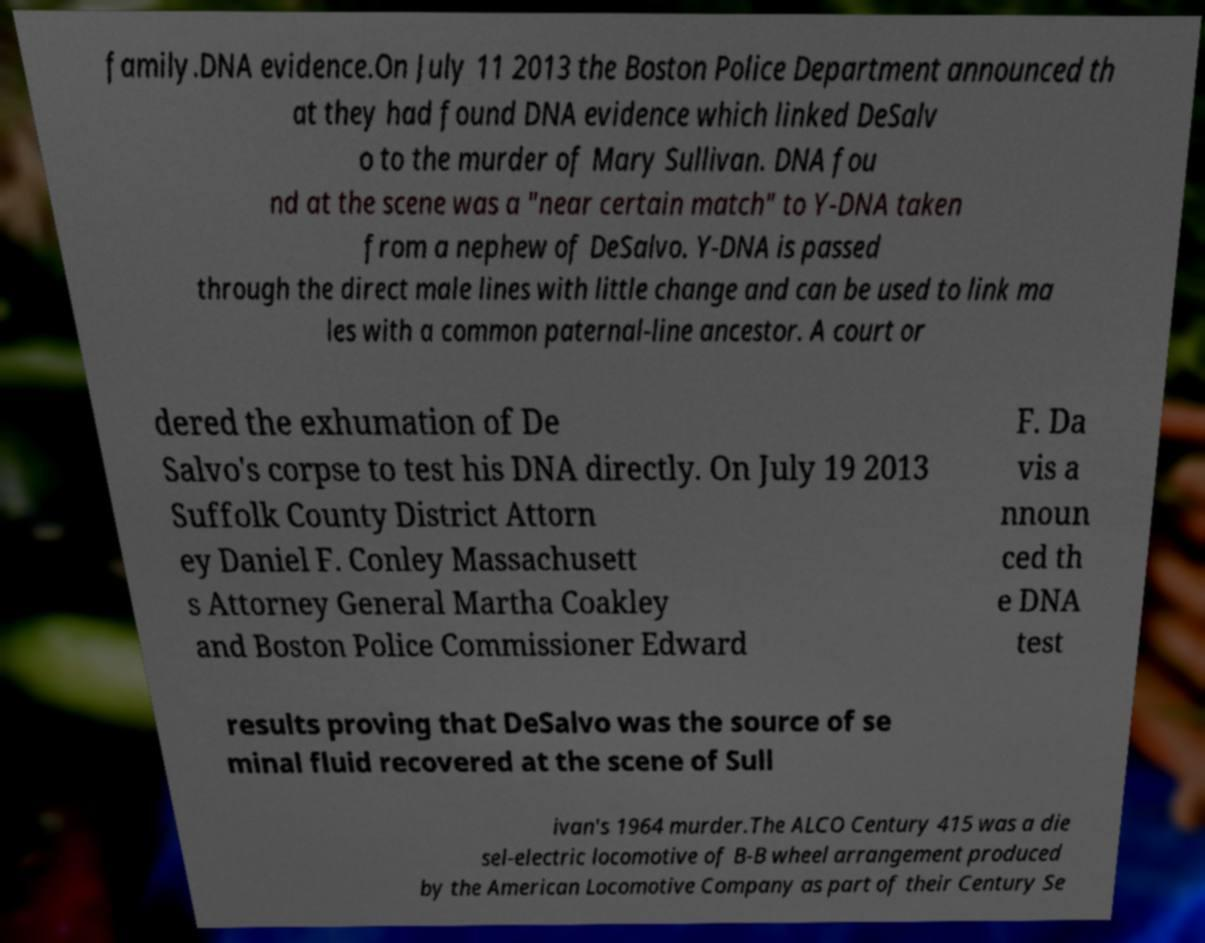I need the written content from this picture converted into text. Can you do that? family.DNA evidence.On July 11 2013 the Boston Police Department announced th at they had found DNA evidence which linked DeSalv o to the murder of Mary Sullivan. DNA fou nd at the scene was a "near certain match" to Y-DNA taken from a nephew of DeSalvo. Y-DNA is passed through the direct male lines with little change and can be used to link ma les with a common paternal-line ancestor. A court or dered the exhumation of De Salvo's corpse to test his DNA directly. On July 19 2013 Suffolk County District Attorn ey Daniel F. Conley Massachusett s Attorney General Martha Coakley and Boston Police Commissioner Edward F. Da vis a nnoun ced th e DNA test results proving that DeSalvo was the source of se minal fluid recovered at the scene of Sull ivan's 1964 murder.The ALCO Century 415 was a die sel-electric locomotive of B-B wheel arrangement produced by the American Locomotive Company as part of their Century Se 